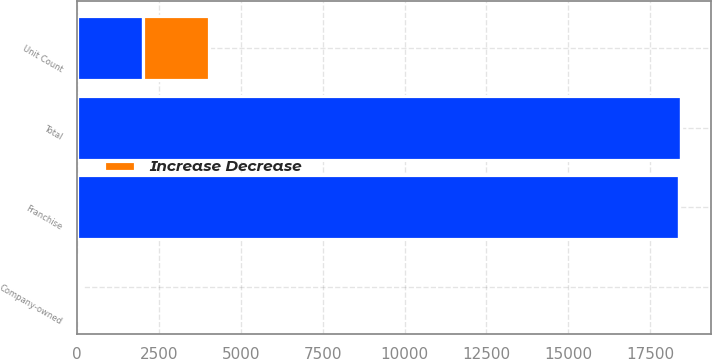<chart> <loc_0><loc_0><loc_500><loc_500><stacked_bar_chart><ecel><fcel>Unit Count<fcel>Franchise<fcel>Company-owned<fcel>Total<nl><fcel>nan<fcel>2018<fcel>18369<fcel>62<fcel>18431<nl><fcel>Increase Decrease<fcel>2018<fcel>11<fcel>61<fcel>10<nl></chart> 